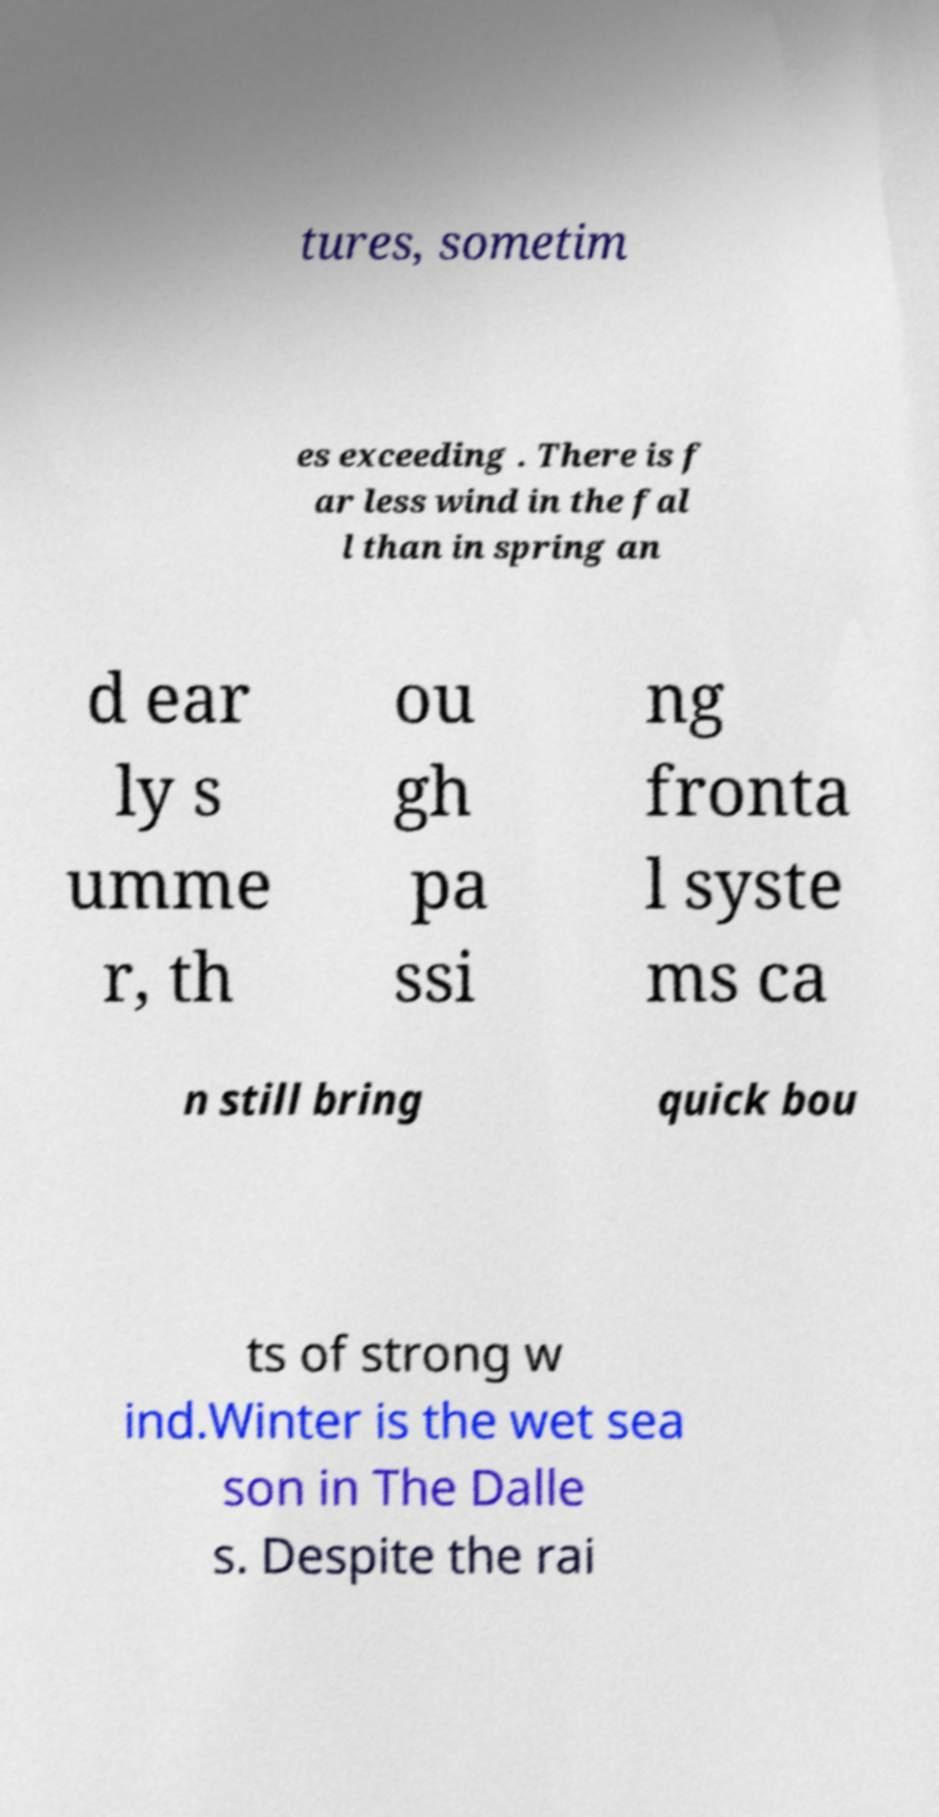Please read and relay the text visible in this image. What does it say? tures, sometim es exceeding . There is f ar less wind in the fal l than in spring an d ear ly s umme r, th ou gh pa ssi ng fronta l syste ms ca n still bring quick bou ts of strong w ind.Winter is the wet sea son in The Dalle s. Despite the rai 